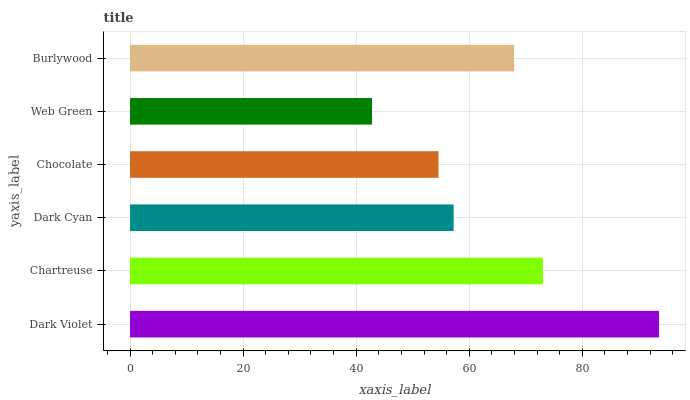Is Web Green the minimum?
Answer yes or no. Yes. Is Dark Violet the maximum?
Answer yes or no. Yes. Is Chartreuse the minimum?
Answer yes or no. No. Is Chartreuse the maximum?
Answer yes or no. No. Is Dark Violet greater than Chartreuse?
Answer yes or no. Yes. Is Chartreuse less than Dark Violet?
Answer yes or no. Yes. Is Chartreuse greater than Dark Violet?
Answer yes or no. No. Is Dark Violet less than Chartreuse?
Answer yes or no. No. Is Burlywood the high median?
Answer yes or no. Yes. Is Dark Cyan the low median?
Answer yes or no. Yes. Is Web Green the high median?
Answer yes or no. No. Is Burlywood the low median?
Answer yes or no. No. 